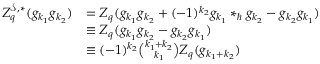<formula> <loc_0><loc_0><loc_500><loc_500>\begin{array} { r l } { Z _ { q } ^ { \mathcal { S } , \ast } ( g _ { k _ { 1 } } g _ { k _ { 2 } } ) } & { = Z _ { q } ( g _ { k _ { 1 } } g _ { k _ { 2 } } + ( - 1 ) ^ { k _ { 2 } } g _ { k _ { 1 } } \ast _ { } g _ { k _ { 2 } } - g _ { k _ { 2 } } g _ { k _ { 1 } } ) } \\ & { \equiv Z _ { q } ( g _ { k _ { 1 } } g _ { k _ { 2 } } - g _ { k _ { 2 } } g _ { k _ { 1 } } ) } \\ & { \equiv ( - 1 ) ^ { k _ { 2 } } \binom { k _ { 1 } + k _ { 2 } } { k _ { 1 } } Z _ { q } ( g _ { k _ { 1 } + k _ { 2 } } ) } \end{array}</formula> 